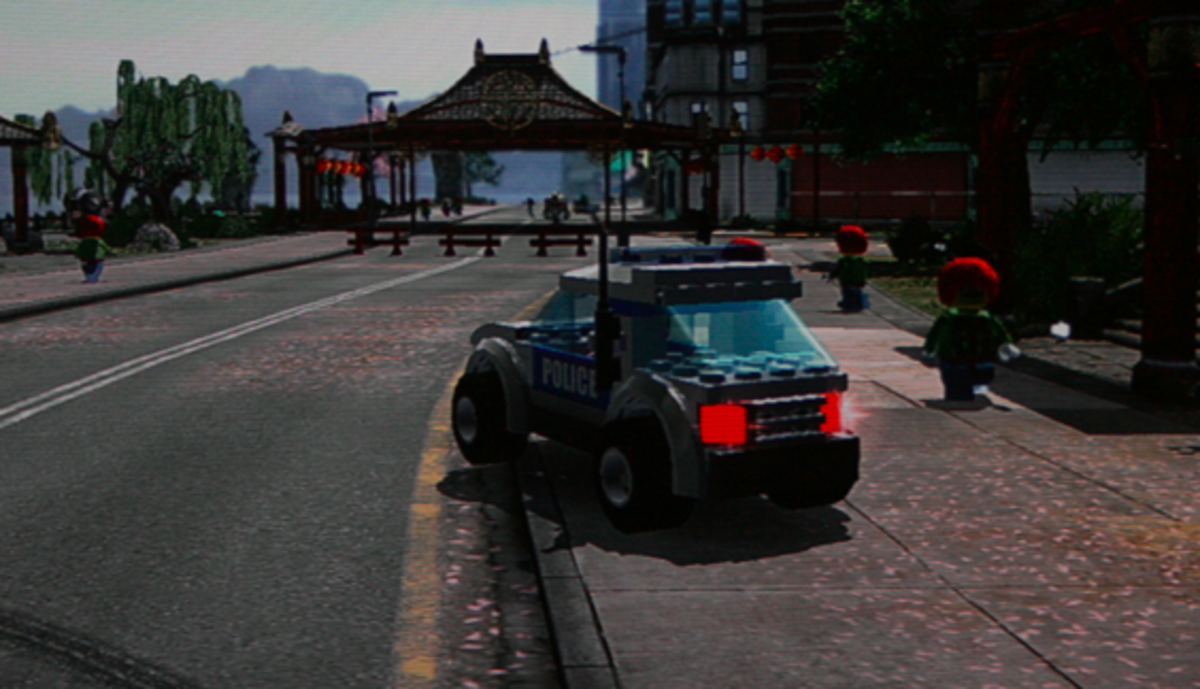Considering the stylization of the characters and the vehicle, what might be the intended audience for the video game from which this scene is likely taken, and why would this style appeal to them? The intended audience for the video game is likely children and possibly fans of building block toys, given the playful and simplified aesthetic that characterizes the scene. The style appeals to this demographic as it resonates with the imaginative play associated with construction toys, allowing for an immersive experience that blends the creativity of building with the interactivity of a digital game. The stylization encourages a lighthearted, accessible atmosphere that is approachable for younger audiences while also tapping into the nostalgia and affection that adult fans may have for such toys from their own childhoods. 